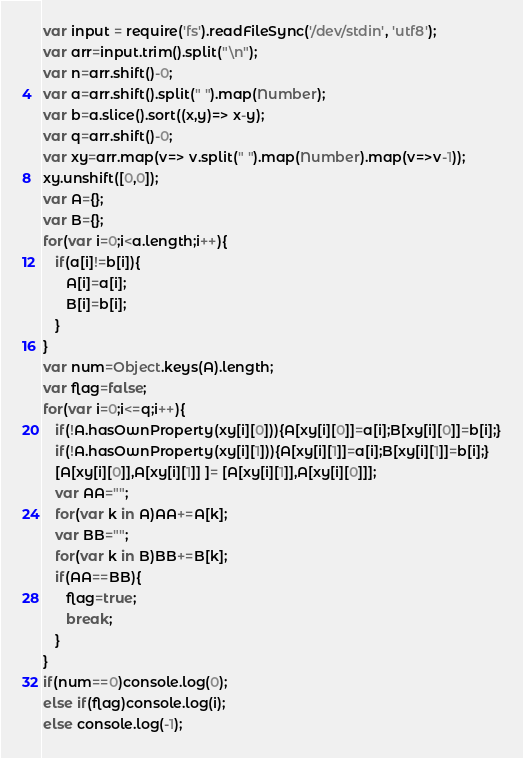<code> <loc_0><loc_0><loc_500><loc_500><_JavaScript_>var input = require('fs').readFileSync('/dev/stdin', 'utf8');
var arr=input.trim().split("\n");
var n=arr.shift()-0;
var a=arr.shift().split(" ").map(Number);
var b=a.slice().sort((x,y)=> x-y);
var q=arr.shift()-0;
var xy=arr.map(v=> v.split(" ").map(Number).map(v=>v-1));
xy.unshift([0,0]);
var A={};
var B={};
for(var i=0;i<a.length;i++){
   if(a[i]!=b[i]){
      A[i]=a[i];
      B[i]=b[i];
   }
}
var num=Object.keys(A).length;
var flag=false;
for(var i=0;i<=q;i++){
   if(!A.hasOwnProperty(xy[i][0])){A[xy[i][0]]=a[i];B[xy[i][0]]=b[i];}
   if(!A.hasOwnProperty(xy[i][1])){A[xy[i][1]]=a[i];B[xy[i][1]]=b[i];}
   [A[xy[i][0]],A[xy[i][1]] ]= [A[xy[i][1]],A[xy[i][0]]];
   var AA="";
   for(var k in A)AA+=A[k];
   var BB="";
   for(var k in B)BB+=B[k];
   if(AA==BB){
      flag=true;
      break;
   }
}
if(num==0)console.log(0);
else if(flag)console.log(i);
else console.log(-1);
</code> 